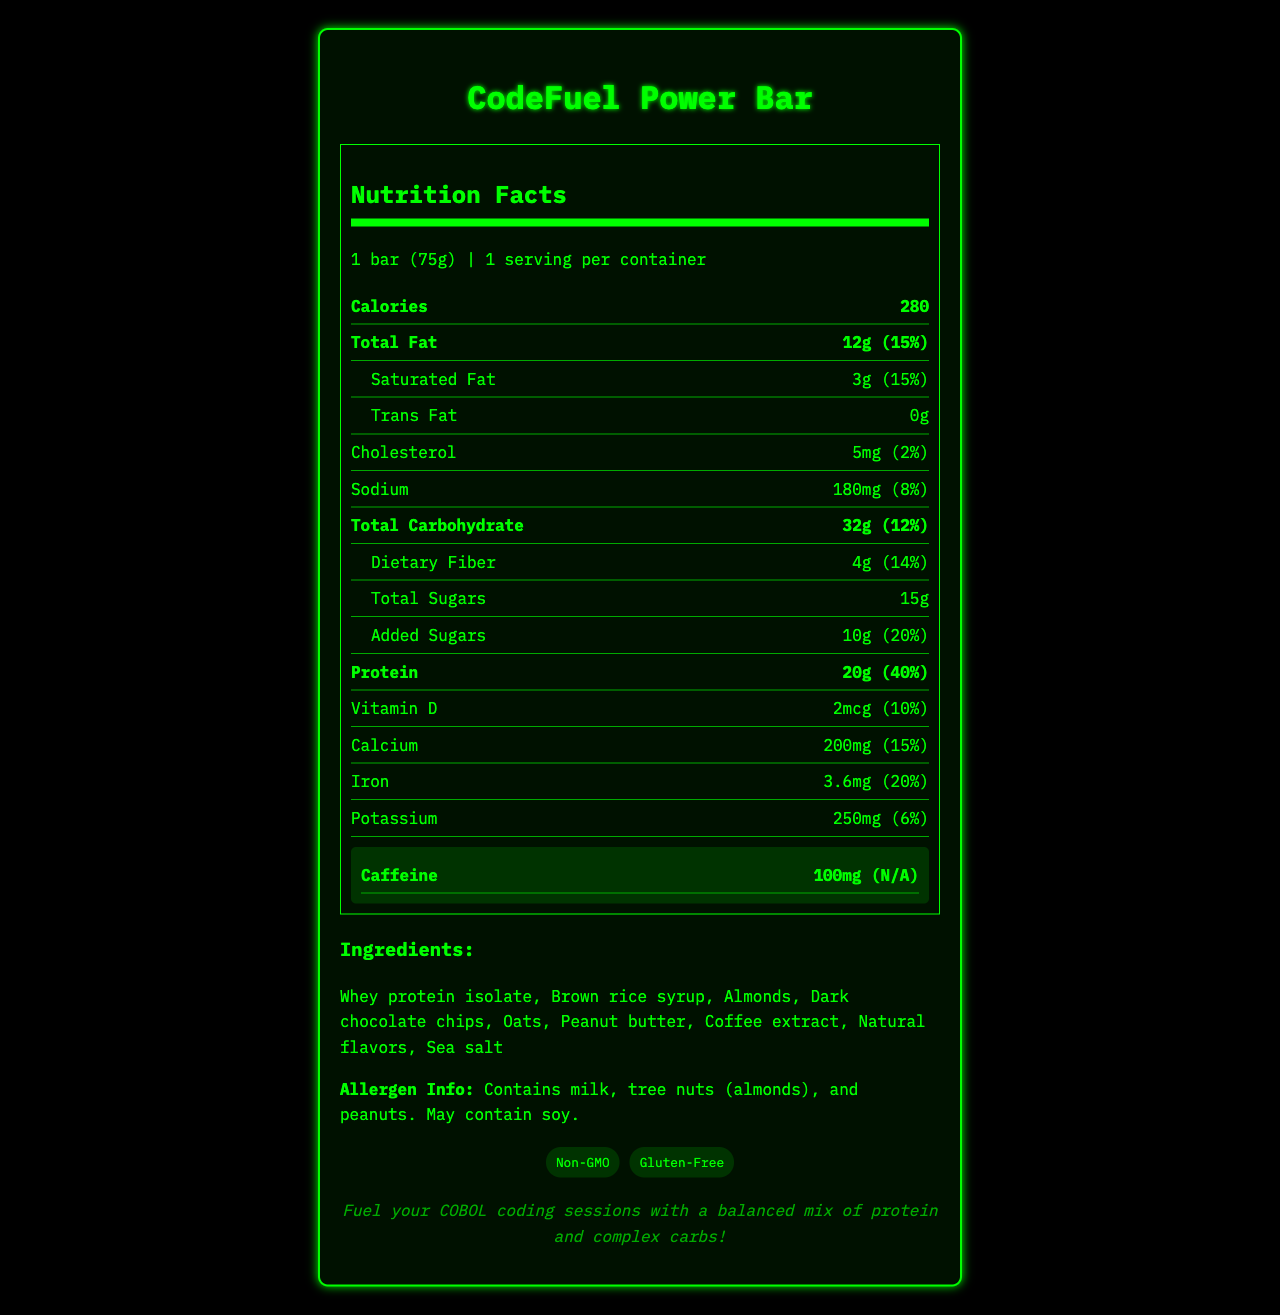what is the serving size of the CodeFuel Power Bar? The serving size is explicitly mentioned at the beginning of the Nutrition Facts section.
Answer: 1 bar (75g) how many calories are in one serving? The calories per serving are listed right under the serving size information.
Answer: 280 what percentage of the daily value of protein does one bar contain? The percentage daily value for protein is mentioned next to the protein amount.
Answer: 40% what is the amount of added sugars in the bar? The amount of added sugars is specified under the Total Sugars section.
Answer: 10g what ingredients are listed for this bar? The ingredients are listed in the Ingredients section.
Answer: Whey protein isolate, Brown rice syrup, Almonds, Dark chocolate chips, Oats, Peanut butter, Coffee extract, Natural flavors, Sea salt how much caffeine is in the CodeFuel Power Bar? The caffeine content is highlighted in its own section and clearly states 100mg.
Answer: 100mg what is the percentage daily value of saturated fat in one bar? The percentage daily value for saturated fat is located right next to its amount in grams.
Answer: 15% does the bar contain any tree nuts? The allergen information explicitly states that it contains tree nuts (almonds).
Answer: Yes on what nutritional label component does dietary fiber fall under? Dietary fiber is listed as a subcategory under Total Carbohydrate in the nutrition facts section.
Answer: Total Carbohydrate which certifications does the CodeFuel Power Bar have? A. Vegan B. Non-GMO C. Organic D. Gluten-Free E. Kosher The certifications listed at the bottom indicate Non-GMO and Gluten-Free.
Answer: B, D what is the main idea of this document? The document thoroughly covers the nutrition facts, ingredient details, certifications, and a mainframe development tip for the CodeFuel Power Bar.
Answer: The document provides a detailed description of the nutrition facts, ingredients, allergen information, and certifications for a protein-rich energy bar called CodeFuel Power Bar, designed specifically for extended coding sessions. It highlights key nutritional values, especially the caffeine content, and includes a reference to mainframe development benefits. what is the percentage daily value of iron? The percentage daily value of iron is mentioned next to its amount in milligrams under the Iron section.
Answer: 20% what are the cholesterol and sodium amounts in the bar? The amounts of cholesterol and sodium are found individually listed in their respective sections.
Answer: Cholesterol: 5mg, Sodium: 180mg what additional information is provided about coding? This information is included as a mainframe development tip at the bottom of the document.
Answer: Fuel your COBOL coding sessions with a balanced mix of protein and complex carbs! how many grams of total sugars are in the bar? The total amount of sugars, including added sugars, is listed under the Total Sugars section.
Answer: 15g what is the vitamin D content per serving? The amount of vitamin D per serving is specifically listed in the nutrition facts.
Answer: 2mcg what is the name of the product described in the document? The product name is prominently displayed as the title of the document.
Answer: CodeFuel Power Bar does the document mention if the bar is vegan? The certifications and ingredients list do not indicate that the bar is vegan.
Answer: No In which section is the percent daily value of potassium mentioned? The percent daily value for potassium is mentioned next to its amount in milligrams under the Potassium section.
Answer: Potassium section 